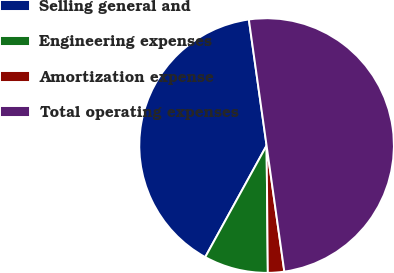Convert chart to OTSL. <chart><loc_0><loc_0><loc_500><loc_500><pie_chart><fcel>Selling general and<fcel>Engineering expenses<fcel>Amortization expense<fcel>Total operating expenses<nl><fcel>39.77%<fcel>8.16%<fcel>2.07%<fcel>50.0%<nl></chart> 